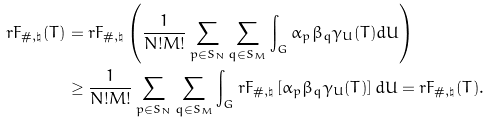Convert formula to latex. <formula><loc_0><loc_0><loc_500><loc_500>r { F } _ { \# , \natural } ( T ) & = r { F } _ { \# , \natural } \left ( \frac { 1 } { N ! M ! } \sum _ { p \in S _ { N } } \sum _ { q \in S _ { M } } \int _ { G } \alpha _ { p } \beta _ { q } \gamma _ { U } ( T ) d U \right ) \\ & \geq \frac { 1 } { N ! M ! } \sum _ { p \in S _ { N } } \sum _ { q \in S _ { M } } \int _ { G } r { F } _ { \# , \natural } \left [ \alpha _ { p } \beta _ { q } \gamma _ { U } ( T ) \right ] d U = r { F } _ { \# , \natural } ( T ) .</formula> 